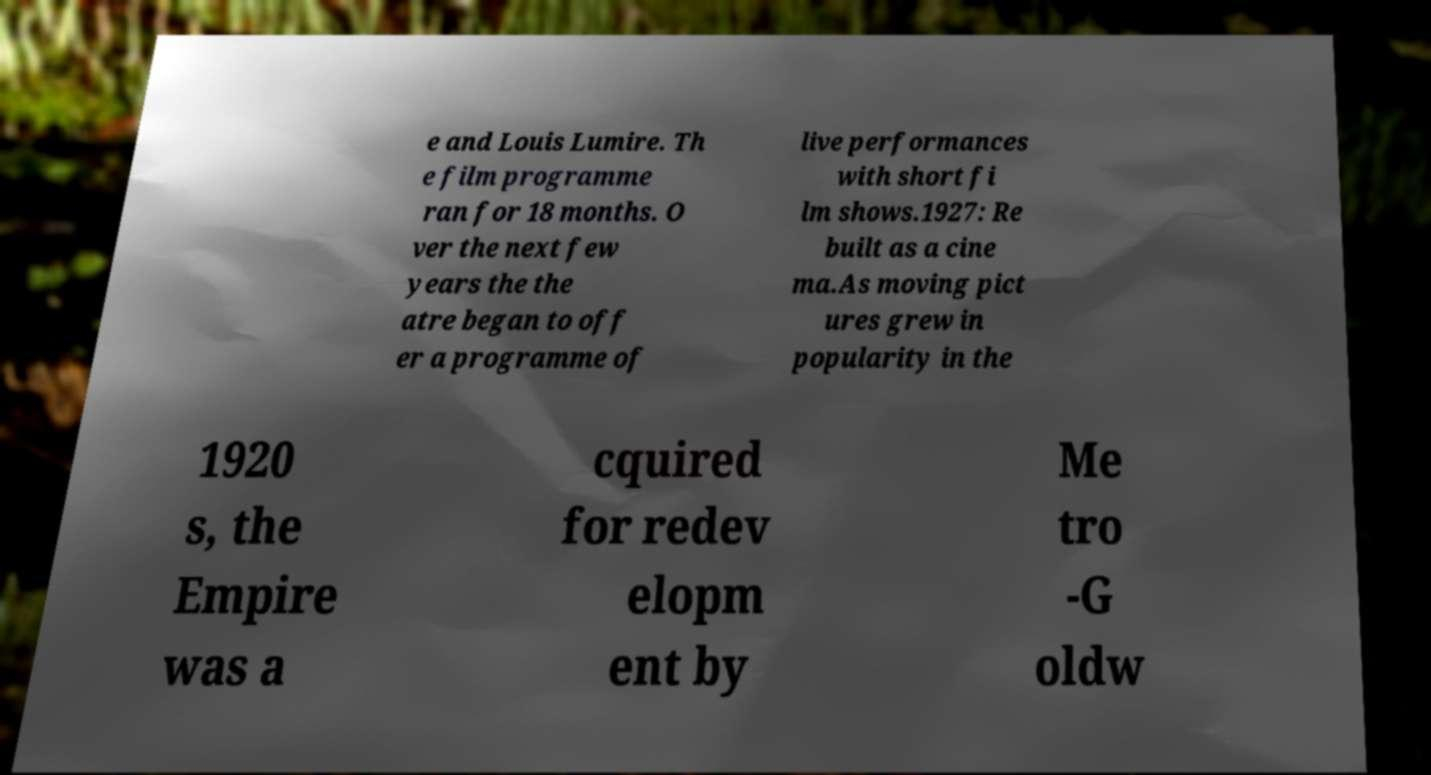Please identify and transcribe the text found in this image. e and Louis Lumire. Th e film programme ran for 18 months. O ver the next few years the the atre began to off er a programme of live performances with short fi lm shows.1927: Re built as a cine ma.As moving pict ures grew in popularity in the 1920 s, the Empire was a cquired for redev elopm ent by Me tro -G oldw 